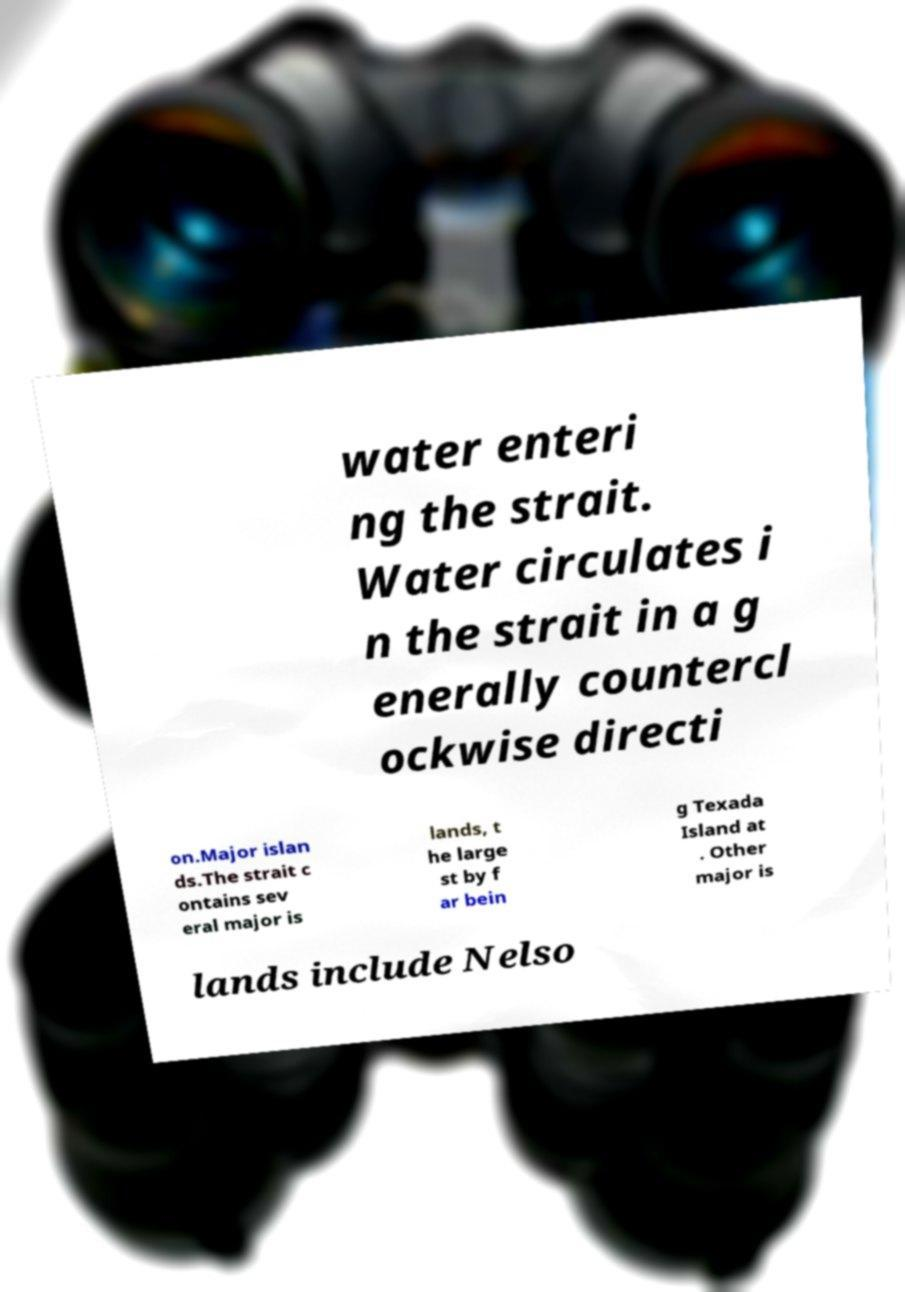There's text embedded in this image that I need extracted. Can you transcribe it verbatim? water enteri ng the strait. Water circulates i n the strait in a g enerally countercl ockwise directi on.Major islan ds.The strait c ontains sev eral major is lands, t he large st by f ar bein g Texada Island at . Other major is lands include Nelso 